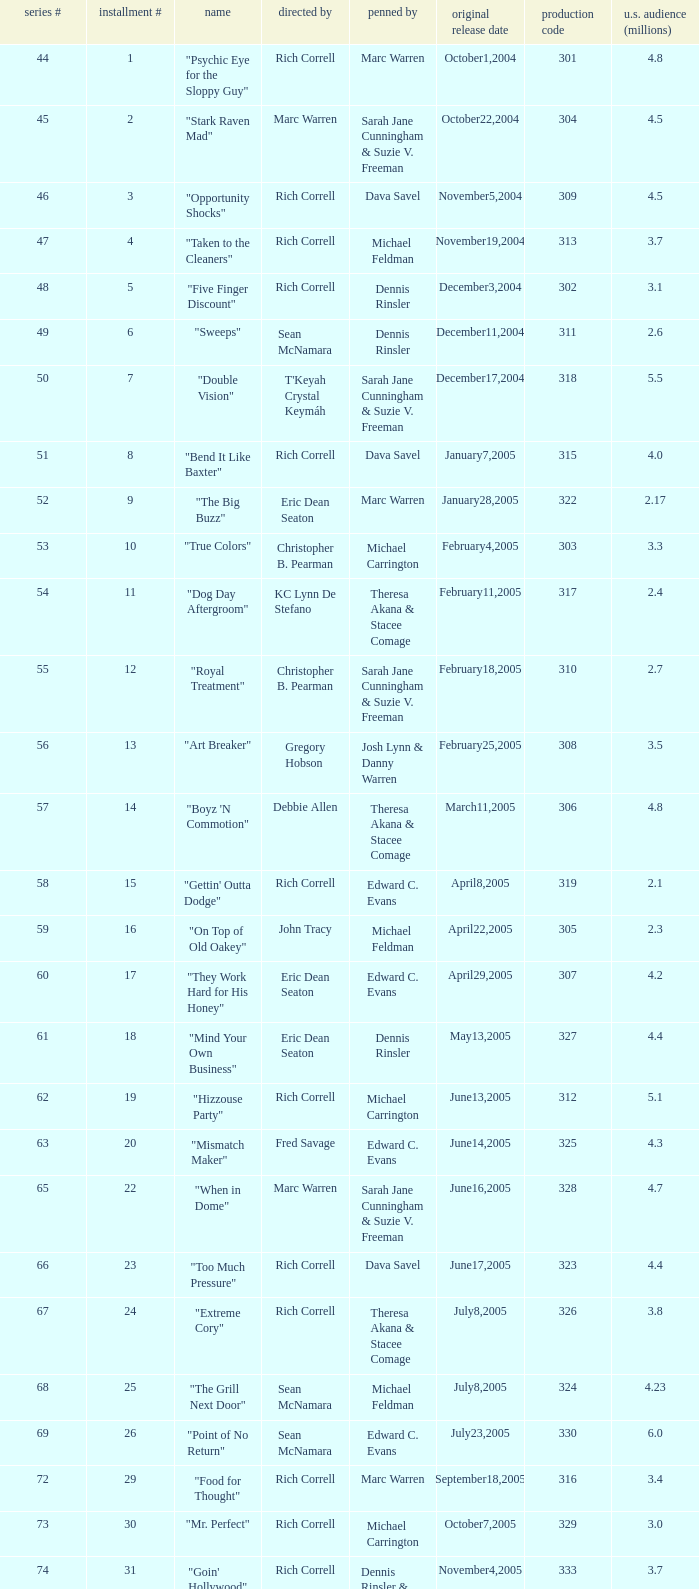What number episode of the season was titled "Vision Impossible"? 34.0. 